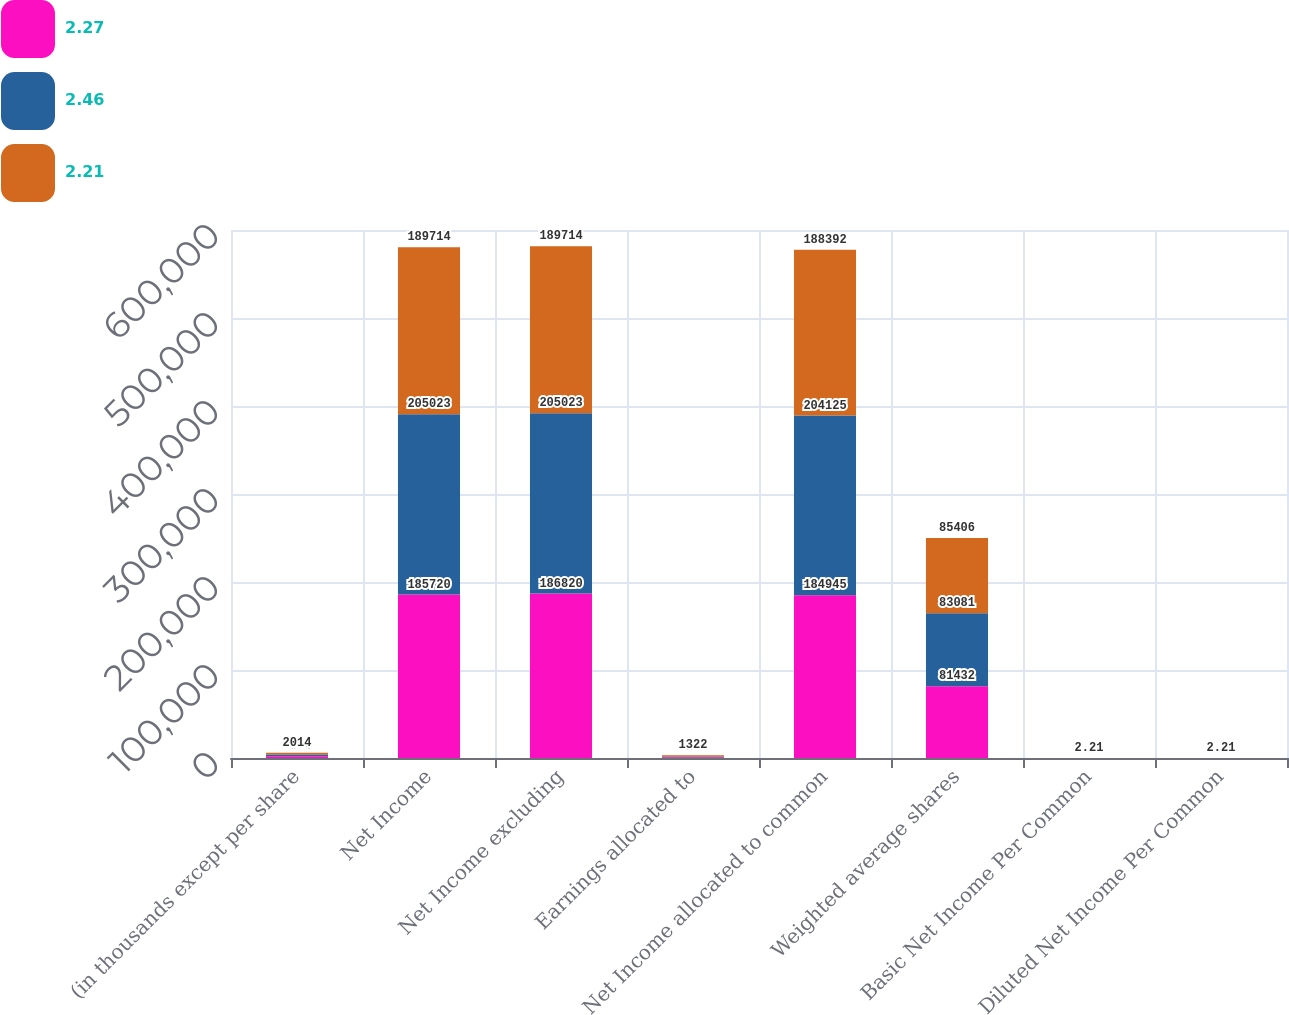<chart> <loc_0><loc_0><loc_500><loc_500><stacked_bar_chart><ecel><fcel>(in thousands except per share<fcel>Net Income<fcel>Net Income excluding<fcel>Earnings allocated to<fcel>Net Income allocated to common<fcel>Weighted average shares<fcel>Basic Net Income Per Common<fcel>Diluted Net Income Per Common<nl><fcel>2.27<fcel>2016<fcel>185720<fcel>186820<fcel>775<fcel>184945<fcel>81432<fcel>2.27<fcel>2.27<nl><fcel>2.46<fcel>2015<fcel>205023<fcel>205023<fcel>898<fcel>204125<fcel>83081<fcel>2.46<fcel>2.46<nl><fcel>2.21<fcel>2014<fcel>189714<fcel>189714<fcel>1322<fcel>188392<fcel>85406<fcel>2.21<fcel>2.21<nl></chart> 